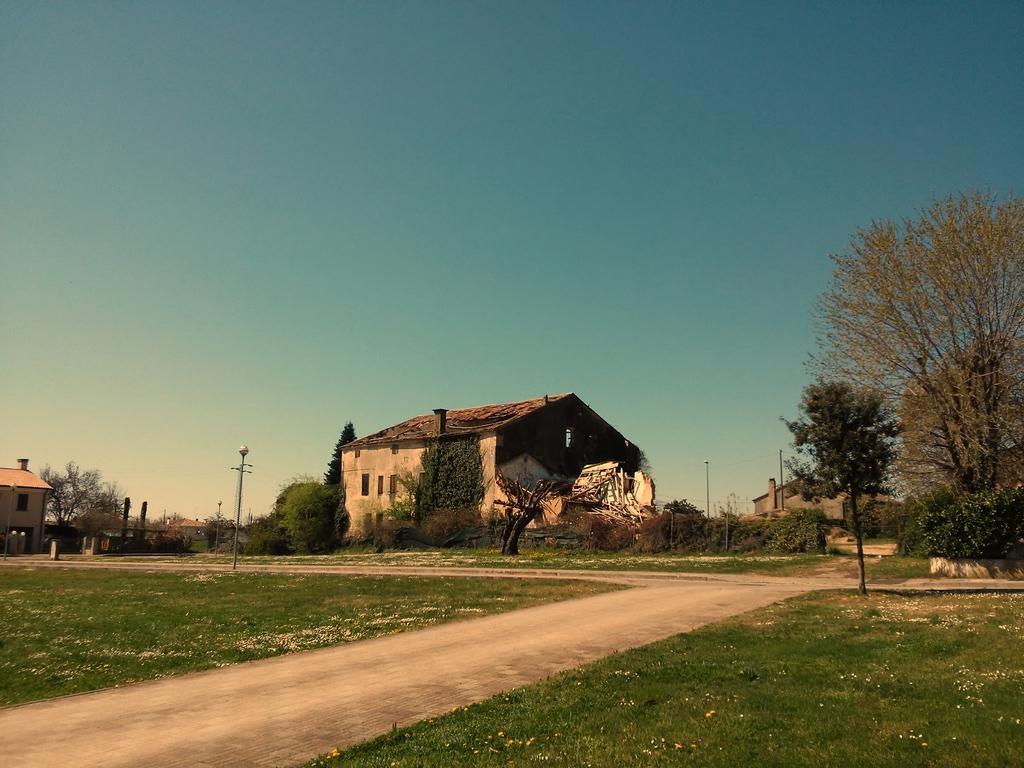In one or two sentences, can you explain what this image depicts? There is a road. On both sides of this road, there is grass on the ground. In the background, there are trees, plants and buildings on the ground and there is blue sky. 